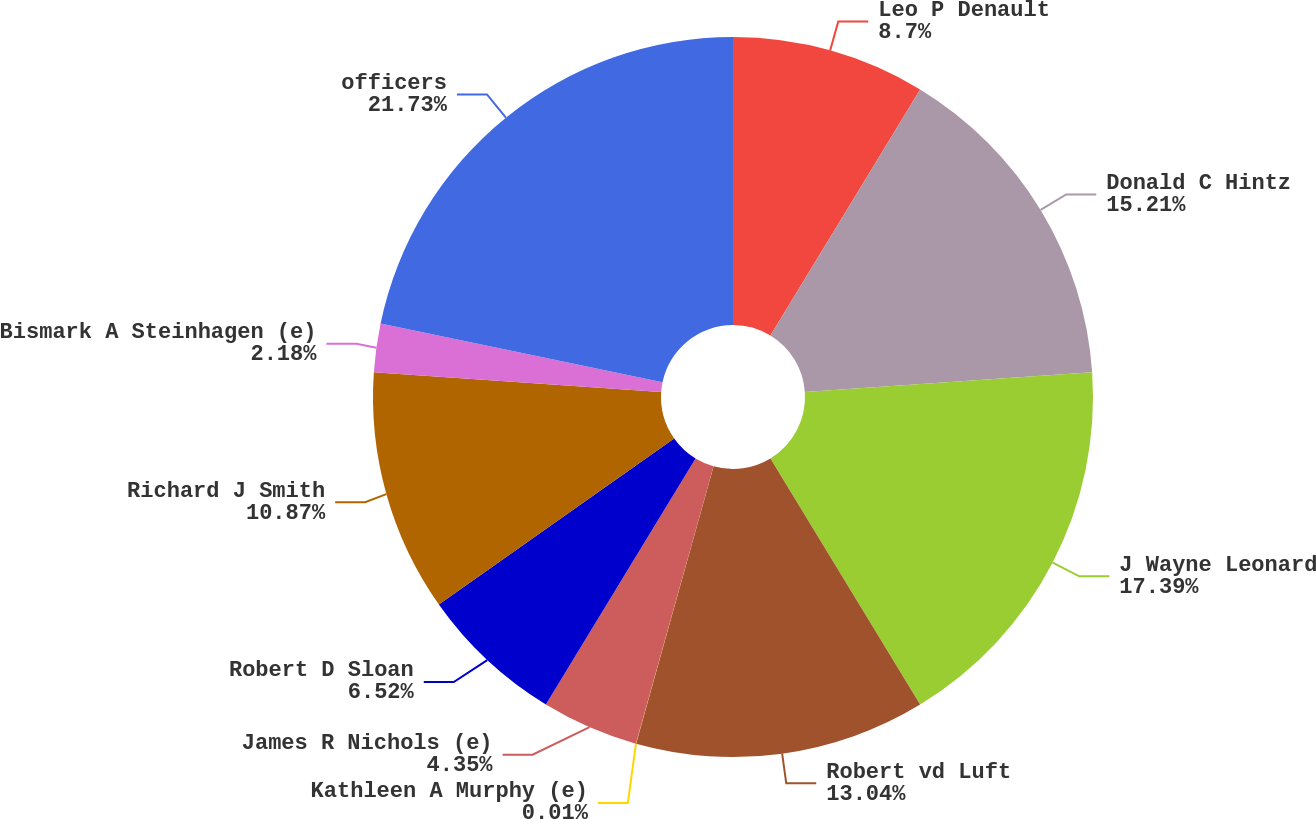Convert chart. <chart><loc_0><loc_0><loc_500><loc_500><pie_chart><fcel>Leo P Denault<fcel>Donald C Hintz<fcel>J Wayne Leonard<fcel>Robert vd Luft<fcel>Kathleen A Murphy (e)<fcel>James R Nichols (e)<fcel>Robert D Sloan<fcel>Richard J Smith<fcel>Bismark A Steinhagen (e)<fcel>officers<nl><fcel>8.7%<fcel>15.21%<fcel>17.39%<fcel>13.04%<fcel>0.01%<fcel>4.35%<fcel>6.52%<fcel>10.87%<fcel>2.18%<fcel>21.73%<nl></chart> 